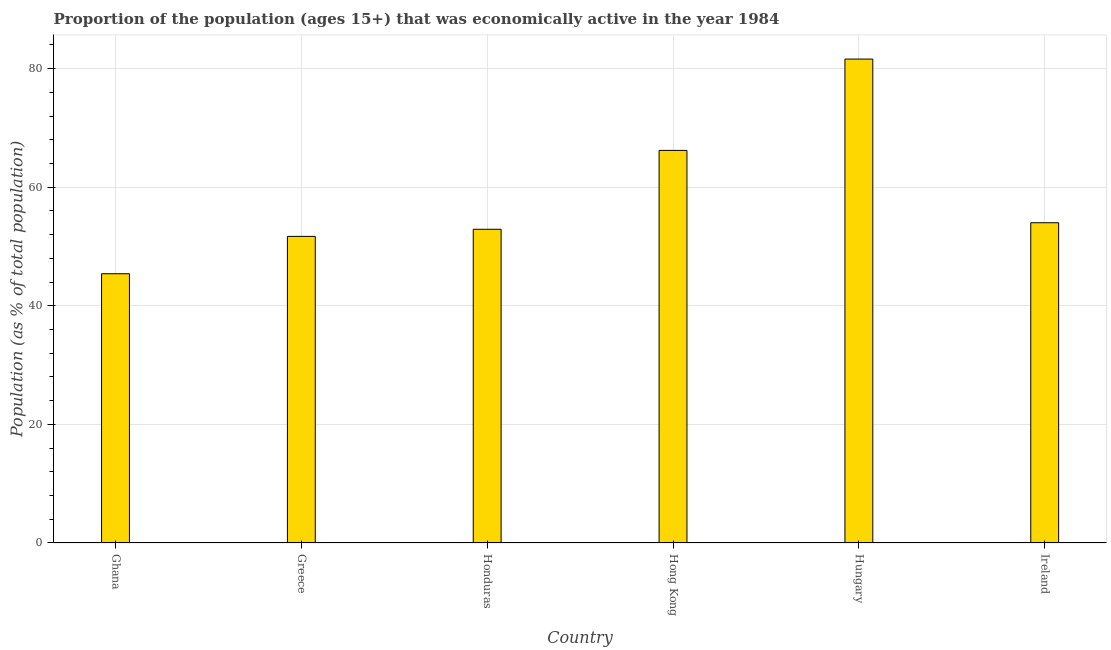Does the graph contain any zero values?
Ensure brevity in your answer.  No. What is the title of the graph?
Your response must be concise. Proportion of the population (ages 15+) that was economically active in the year 1984. What is the label or title of the Y-axis?
Provide a succinct answer. Population (as % of total population). What is the percentage of economically active population in Hungary?
Give a very brief answer. 81.6. Across all countries, what is the maximum percentage of economically active population?
Offer a terse response. 81.6. Across all countries, what is the minimum percentage of economically active population?
Give a very brief answer. 45.4. In which country was the percentage of economically active population maximum?
Offer a terse response. Hungary. In which country was the percentage of economically active population minimum?
Make the answer very short. Ghana. What is the sum of the percentage of economically active population?
Offer a very short reply. 351.8. What is the difference between the percentage of economically active population in Ghana and Ireland?
Make the answer very short. -8.6. What is the average percentage of economically active population per country?
Offer a very short reply. 58.63. What is the median percentage of economically active population?
Keep it short and to the point. 53.45. In how many countries, is the percentage of economically active population greater than 68 %?
Provide a short and direct response. 1. What is the ratio of the percentage of economically active population in Ghana to that in Greece?
Offer a terse response. 0.88. Is the percentage of economically active population in Honduras less than that in Ireland?
Offer a terse response. Yes. Is the difference between the percentage of economically active population in Ghana and Ireland greater than the difference between any two countries?
Your answer should be very brief. No. What is the difference between the highest and the lowest percentage of economically active population?
Provide a short and direct response. 36.2. In how many countries, is the percentage of economically active population greater than the average percentage of economically active population taken over all countries?
Your response must be concise. 2. What is the difference between two consecutive major ticks on the Y-axis?
Your response must be concise. 20. Are the values on the major ticks of Y-axis written in scientific E-notation?
Give a very brief answer. No. What is the Population (as % of total population) in Ghana?
Provide a short and direct response. 45.4. What is the Population (as % of total population) in Greece?
Offer a very short reply. 51.7. What is the Population (as % of total population) of Honduras?
Offer a terse response. 52.9. What is the Population (as % of total population) of Hong Kong?
Offer a very short reply. 66.2. What is the Population (as % of total population) in Hungary?
Give a very brief answer. 81.6. What is the difference between the Population (as % of total population) in Ghana and Greece?
Your answer should be very brief. -6.3. What is the difference between the Population (as % of total population) in Ghana and Hong Kong?
Provide a succinct answer. -20.8. What is the difference between the Population (as % of total population) in Ghana and Hungary?
Provide a short and direct response. -36.2. What is the difference between the Population (as % of total population) in Ghana and Ireland?
Your answer should be compact. -8.6. What is the difference between the Population (as % of total population) in Greece and Hong Kong?
Give a very brief answer. -14.5. What is the difference between the Population (as % of total population) in Greece and Hungary?
Offer a very short reply. -29.9. What is the difference between the Population (as % of total population) in Greece and Ireland?
Provide a short and direct response. -2.3. What is the difference between the Population (as % of total population) in Honduras and Hong Kong?
Give a very brief answer. -13.3. What is the difference between the Population (as % of total population) in Honduras and Hungary?
Offer a very short reply. -28.7. What is the difference between the Population (as % of total population) in Hong Kong and Hungary?
Give a very brief answer. -15.4. What is the difference between the Population (as % of total population) in Hungary and Ireland?
Give a very brief answer. 27.6. What is the ratio of the Population (as % of total population) in Ghana to that in Greece?
Provide a succinct answer. 0.88. What is the ratio of the Population (as % of total population) in Ghana to that in Honduras?
Offer a terse response. 0.86. What is the ratio of the Population (as % of total population) in Ghana to that in Hong Kong?
Ensure brevity in your answer.  0.69. What is the ratio of the Population (as % of total population) in Ghana to that in Hungary?
Ensure brevity in your answer.  0.56. What is the ratio of the Population (as % of total population) in Ghana to that in Ireland?
Offer a very short reply. 0.84. What is the ratio of the Population (as % of total population) in Greece to that in Honduras?
Provide a succinct answer. 0.98. What is the ratio of the Population (as % of total population) in Greece to that in Hong Kong?
Ensure brevity in your answer.  0.78. What is the ratio of the Population (as % of total population) in Greece to that in Hungary?
Your response must be concise. 0.63. What is the ratio of the Population (as % of total population) in Honduras to that in Hong Kong?
Ensure brevity in your answer.  0.8. What is the ratio of the Population (as % of total population) in Honduras to that in Hungary?
Give a very brief answer. 0.65. What is the ratio of the Population (as % of total population) in Honduras to that in Ireland?
Make the answer very short. 0.98. What is the ratio of the Population (as % of total population) in Hong Kong to that in Hungary?
Make the answer very short. 0.81. What is the ratio of the Population (as % of total population) in Hong Kong to that in Ireland?
Your answer should be compact. 1.23. What is the ratio of the Population (as % of total population) in Hungary to that in Ireland?
Make the answer very short. 1.51. 